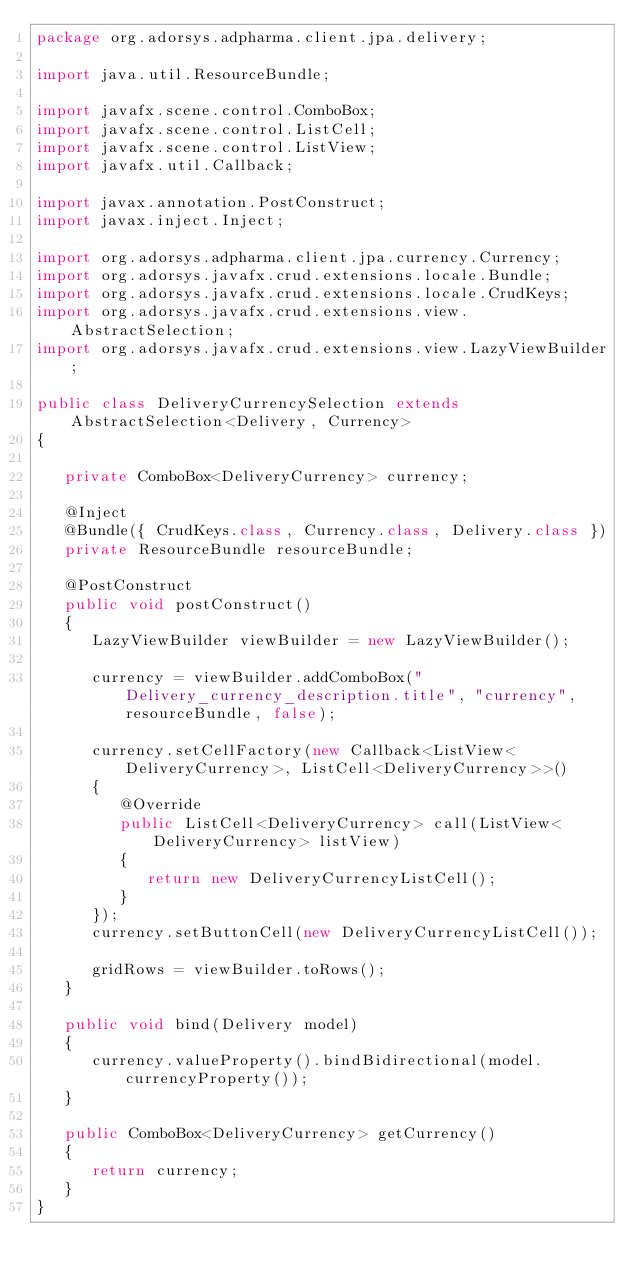Convert code to text. <code><loc_0><loc_0><loc_500><loc_500><_Java_>package org.adorsys.adpharma.client.jpa.delivery;

import java.util.ResourceBundle;

import javafx.scene.control.ComboBox;
import javafx.scene.control.ListCell;
import javafx.scene.control.ListView;
import javafx.util.Callback;

import javax.annotation.PostConstruct;
import javax.inject.Inject;

import org.adorsys.adpharma.client.jpa.currency.Currency;
import org.adorsys.javafx.crud.extensions.locale.Bundle;
import org.adorsys.javafx.crud.extensions.locale.CrudKeys;
import org.adorsys.javafx.crud.extensions.view.AbstractSelection;
import org.adorsys.javafx.crud.extensions.view.LazyViewBuilder;

public class DeliveryCurrencySelection extends AbstractSelection<Delivery, Currency>
{

   private ComboBox<DeliveryCurrency> currency;

   @Inject
   @Bundle({ CrudKeys.class, Currency.class, Delivery.class })
   private ResourceBundle resourceBundle;

   @PostConstruct
   public void postConstruct()
   {
      LazyViewBuilder viewBuilder = new LazyViewBuilder();

      currency = viewBuilder.addComboBox("Delivery_currency_description.title", "currency", resourceBundle, false);

      currency.setCellFactory(new Callback<ListView<DeliveryCurrency>, ListCell<DeliveryCurrency>>()
      {
         @Override
         public ListCell<DeliveryCurrency> call(ListView<DeliveryCurrency> listView)
         {
            return new DeliveryCurrencyListCell();
         }
      });
      currency.setButtonCell(new DeliveryCurrencyListCell());

      gridRows = viewBuilder.toRows();
   }

   public void bind(Delivery model)
   {
      currency.valueProperty().bindBidirectional(model.currencyProperty());
   }

   public ComboBox<DeliveryCurrency> getCurrency()
   {
      return currency;
   }
}
</code> 